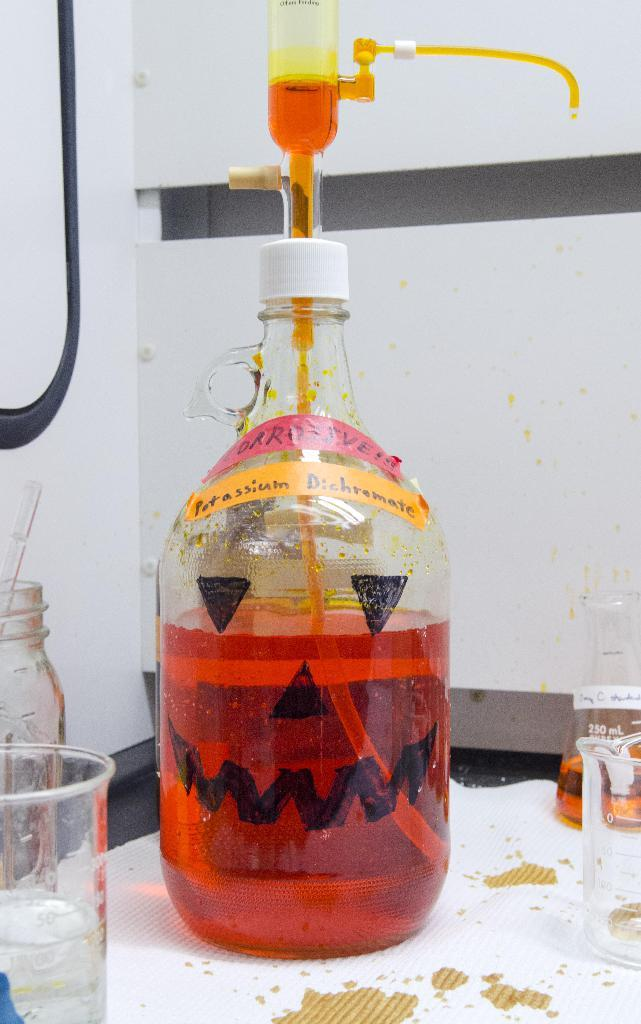What can be seen in the center of the image? There is a bottle containing a liquid in the center of the image. What other containers are present in the image? There is a jar in the image. Where are the beakers located in the image? There are two beakers on the top of a table. What is visible in the background of the image? There is a wall visible in the background of the image. What type of leg is visible in the image? There are no legs visible in the image; it is a picture of the inside of a location with various containers and a wall in the background. 